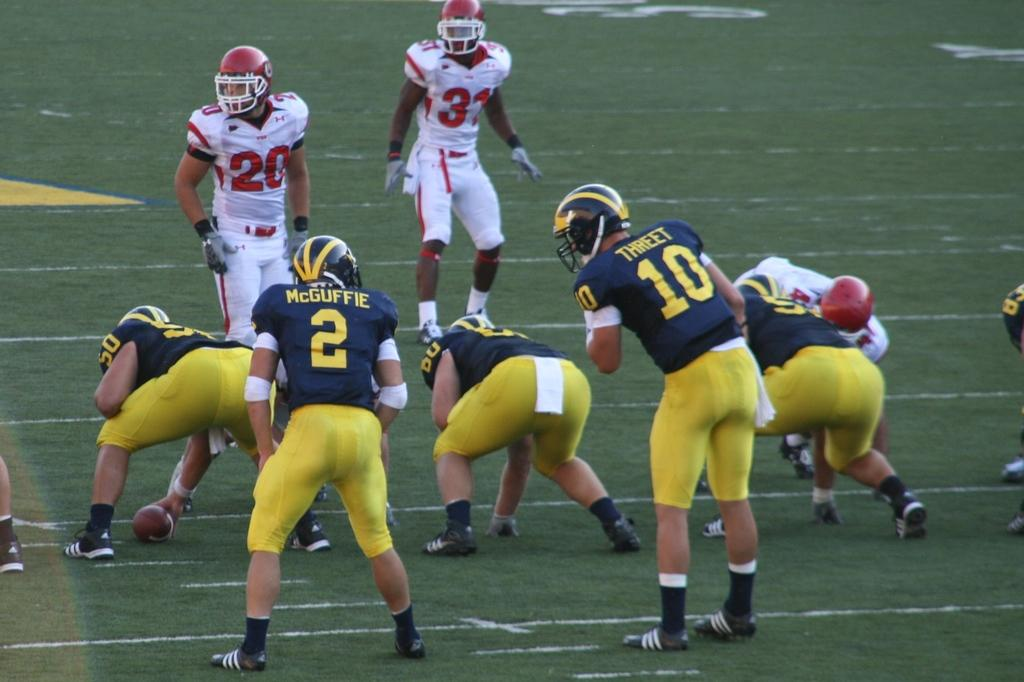Who is present in the image? There are people in the image. What are the people doing in the image? The people are standing and watching. What activity are the people engaged in? The people are playing with a rugby ball. What type of surface can be seen in the image? There is grass visible in the image. What type of scissors can be seen in the image? There are no scissors present in the image. What religious symbols can be seen in the image? There is no mention of any religious symbols in the image. 